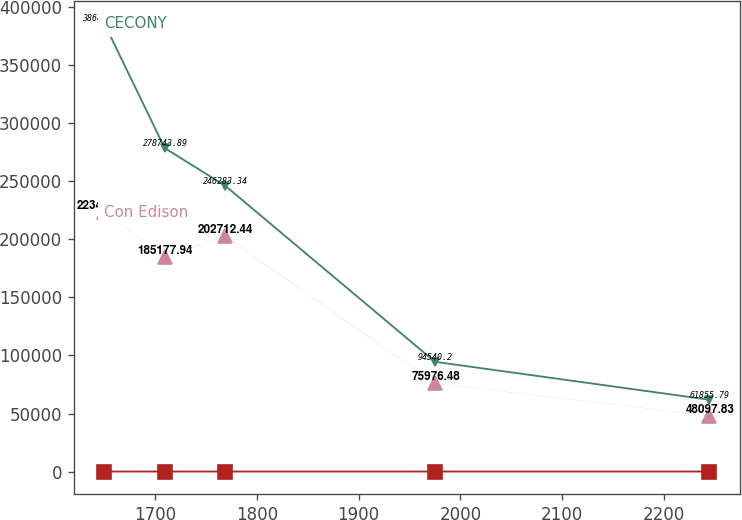Convert chart. <chart><loc_0><loc_0><loc_500><loc_500><line_chart><ecel><fcel>Unnamed: 1<fcel>CECONY<fcel>Con Edison<nl><fcel>1650.2<fcel>3.5<fcel>386461<fcel>223443<nl><fcel>1709.62<fcel>2.99<fcel>278744<fcel>185178<nl><fcel>1769.04<fcel>2.02<fcel>246283<fcel>202712<nl><fcel>1974.99<fcel>0.89<fcel>94540.2<fcel>75976.5<nl><fcel>2244.38<fcel>1.15<fcel>61855.8<fcel>48097.8<nl></chart> 